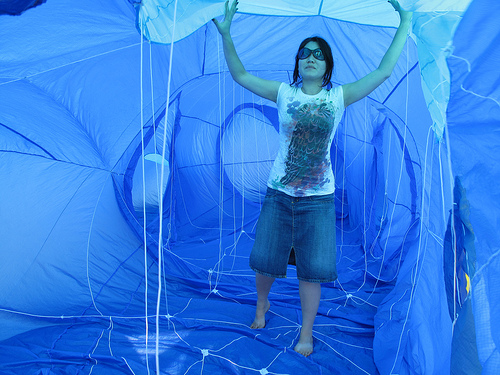<image>
Is the woman in front of the balloon? Yes. The woman is positioned in front of the balloon, appearing closer to the camera viewpoint. 